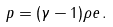Convert formula to latex. <formula><loc_0><loc_0><loc_500><loc_500>p = ( \gamma - 1 ) \rho e \, .</formula> 